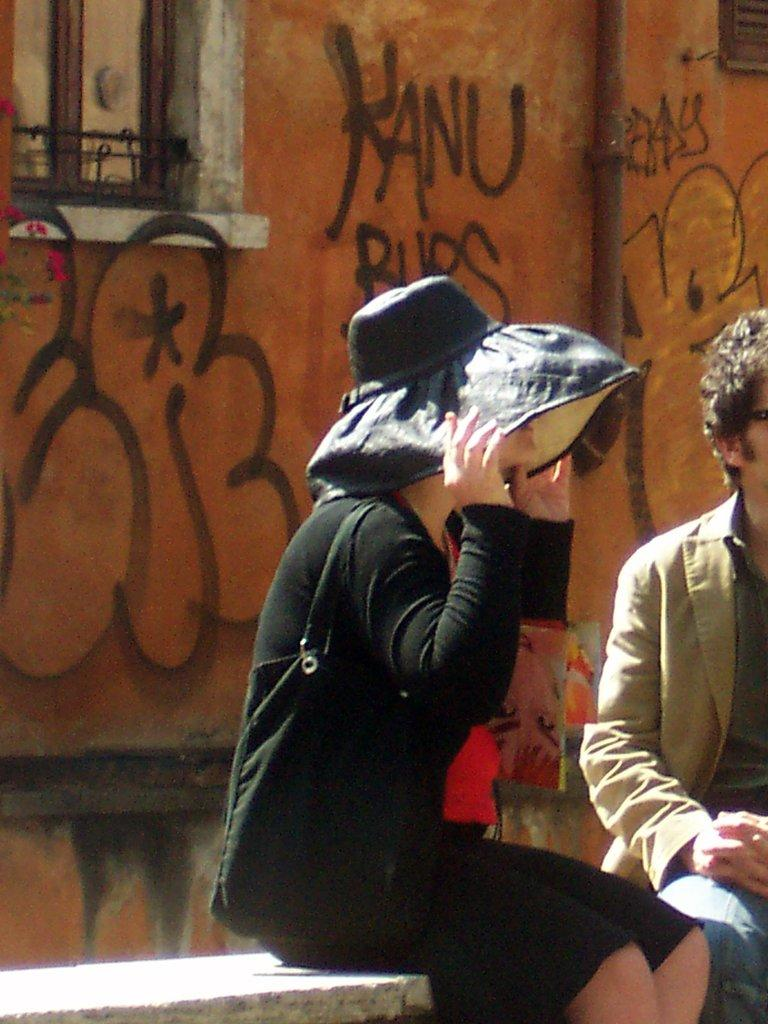<image>
Summarize the visual content of the image. A lady sitting on a bench holding on to her hat in front of a wall with graffiti on it that says Kanu right behind her. 